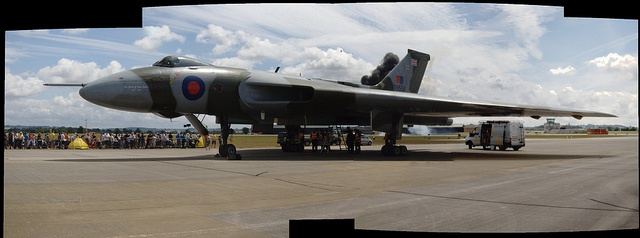Describe the objects in this image and their specific colors. I can see airplane in black, gray, darkgray, and lightgray tones, people in black, gray, olive, and maroon tones, truck in black and gray tones, people in black, gray, maroon, and purple tones, and people in black and maroon tones in this image. 